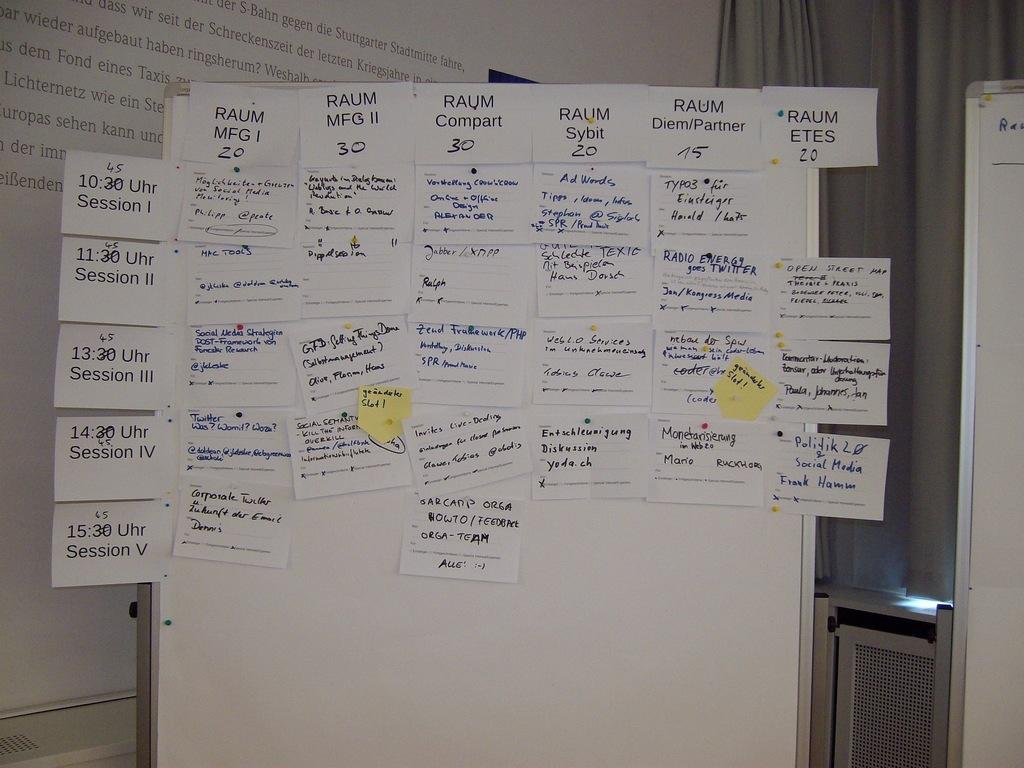<image>
Present a compact description of the photo's key features. "RAUM MFG 1" is written on one of many papers. 